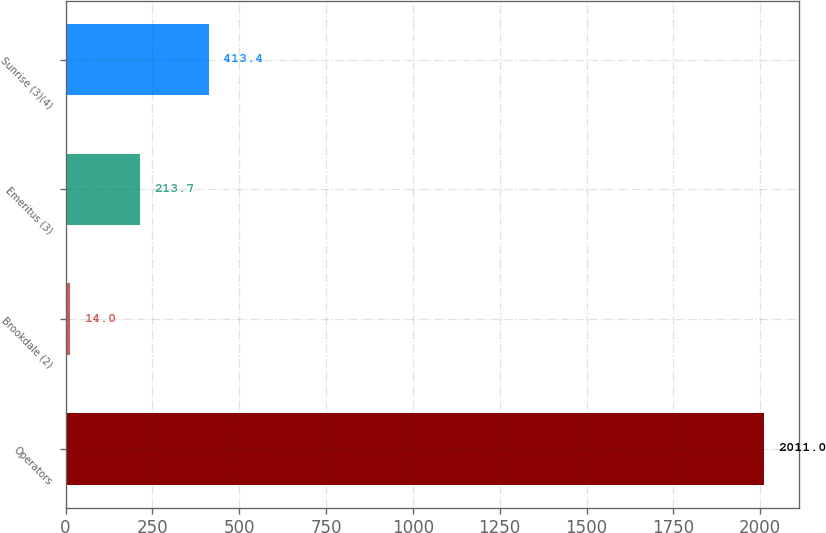<chart> <loc_0><loc_0><loc_500><loc_500><bar_chart><fcel>Operators<fcel>Brookdale (2)<fcel>Emeritus (3)<fcel>Sunrise (3)(4)<nl><fcel>2011<fcel>14<fcel>213.7<fcel>413.4<nl></chart> 